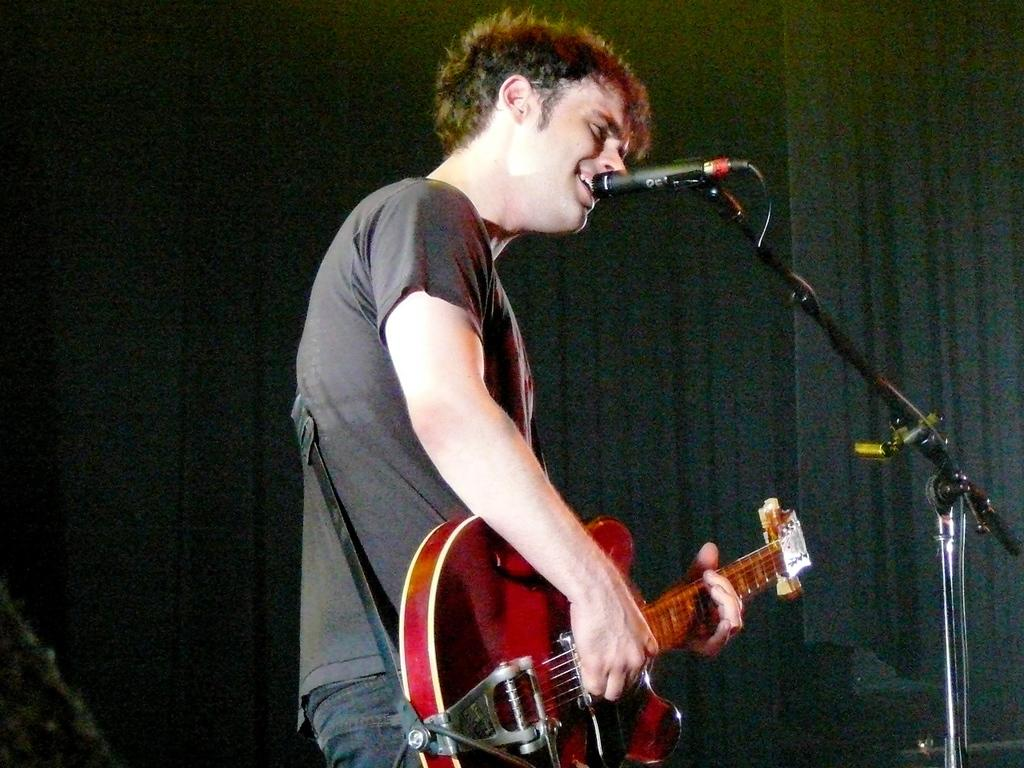What is the person in the image doing? The person is standing, playing a guitar, and singing. What object is in front of the person? There is a microphone in front of the person. What type of class is being taught at the border in the image? There is no class or border present in the image; the person is playing a guitar and singing. 